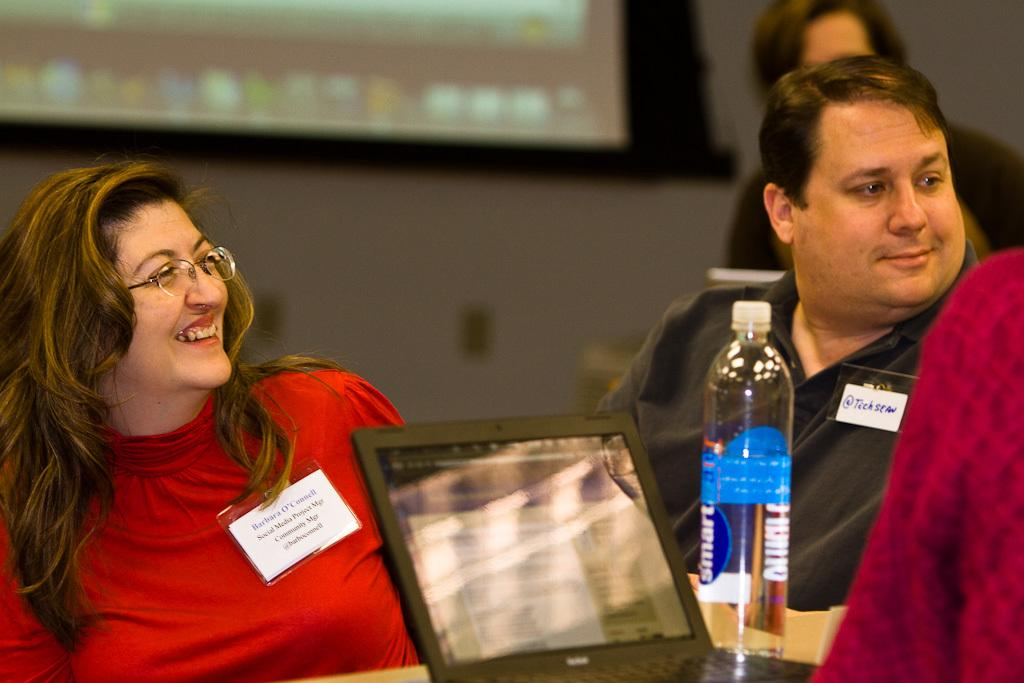Who is present in the image? There is a woman, a mine, and a person standing behind them in the image. What is the facial expression of the woman? The woman has a smile on her face. What is the facial expression of the mine? The mine also has a smile on their face. What objects can be seen in the image related to technology? There is a screen and a laptop in the image. What item can be seen on a table in the image? There is a water bottle on a table in the image. What type of letters can be seen on the bed in the image? There is no bed present in the image, and therefore no letters can be seen on it. 